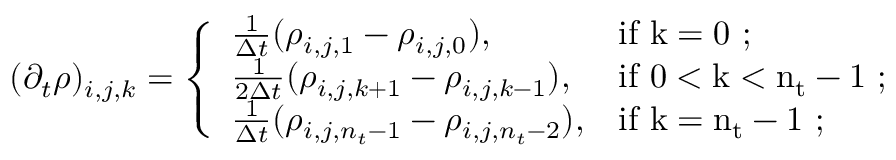Convert formula to latex. <formula><loc_0><loc_0><loc_500><loc_500>\begin{array} { r } { ( \partial _ { t } \rho ) _ { i , j , k } = \left \{ \begin{array} { l l } { \frac { 1 } { \Delta t } ( \rho _ { i , j , 1 } - \rho _ { i , j , 0 } ) , } & { i f k = 0 ; } \\ { \frac { 1 } { 2 \Delta t } ( \rho _ { i , j , k + 1 } - \rho _ { i , j , k - 1 } ) , } & { i f 0 < k < n _ { t } - 1 ; } \\ { \frac { 1 } { \Delta t } ( \rho _ { i , j , n _ { t } - 1 } - \rho _ { i , j , n _ { t } - 2 } ) , } & { i f k = n _ { t } - 1 ; } \end{array} } \end{array}</formula> 